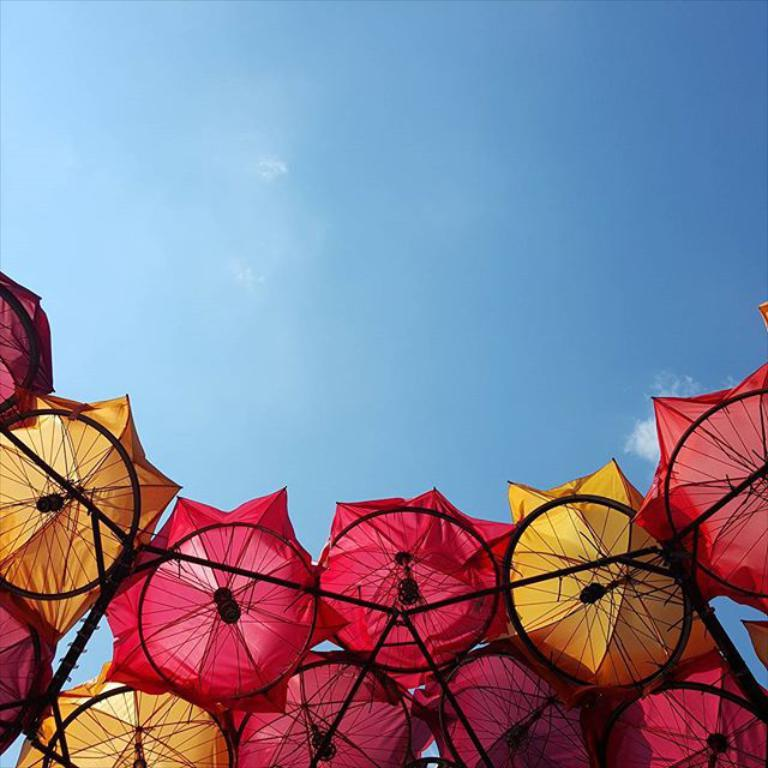What objects are present in the image that can provide shelter from the rain? There are umbrellas in the image that can provide shelter from the rain. What are the long, thin, and straight objects in the image? There are rods in the image. What can be seen in the background of the image? The sky is visible in the image. What type of note is being played on the musical instrument in the image? There is no musical instrument present in the image, so it is not possible to determine what type of note might be played. 